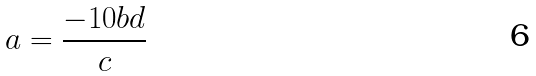Convert formula to latex. <formula><loc_0><loc_0><loc_500><loc_500>a = \frac { - 1 0 b d } { c }</formula> 